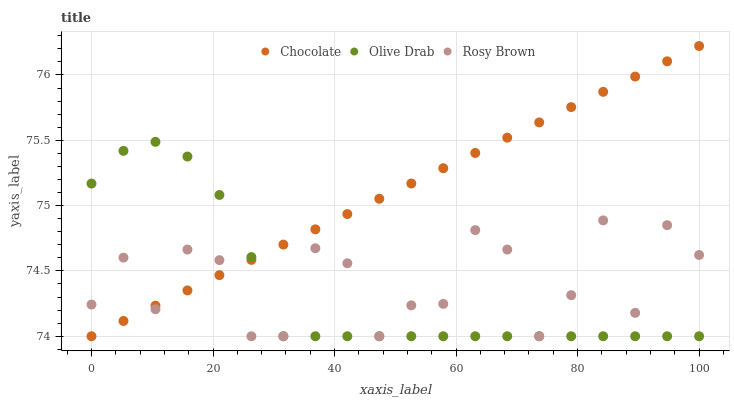Does Olive Drab have the minimum area under the curve?
Answer yes or no. Yes. Does Chocolate have the maximum area under the curve?
Answer yes or no. Yes. Does Chocolate have the minimum area under the curve?
Answer yes or no. No. Does Olive Drab have the maximum area under the curve?
Answer yes or no. No. Is Chocolate the smoothest?
Answer yes or no. Yes. Is Rosy Brown the roughest?
Answer yes or no. Yes. Is Olive Drab the smoothest?
Answer yes or no. No. Is Olive Drab the roughest?
Answer yes or no. No. Does Rosy Brown have the lowest value?
Answer yes or no. Yes. Does Chocolate have the highest value?
Answer yes or no. Yes. Does Olive Drab have the highest value?
Answer yes or no. No. Does Chocolate intersect Olive Drab?
Answer yes or no. Yes. Is Chocolate less than Olive Drab?
Answer yes or no. No. Is Chocolate greater than Olive Drab?
Answer yes or no. No. 